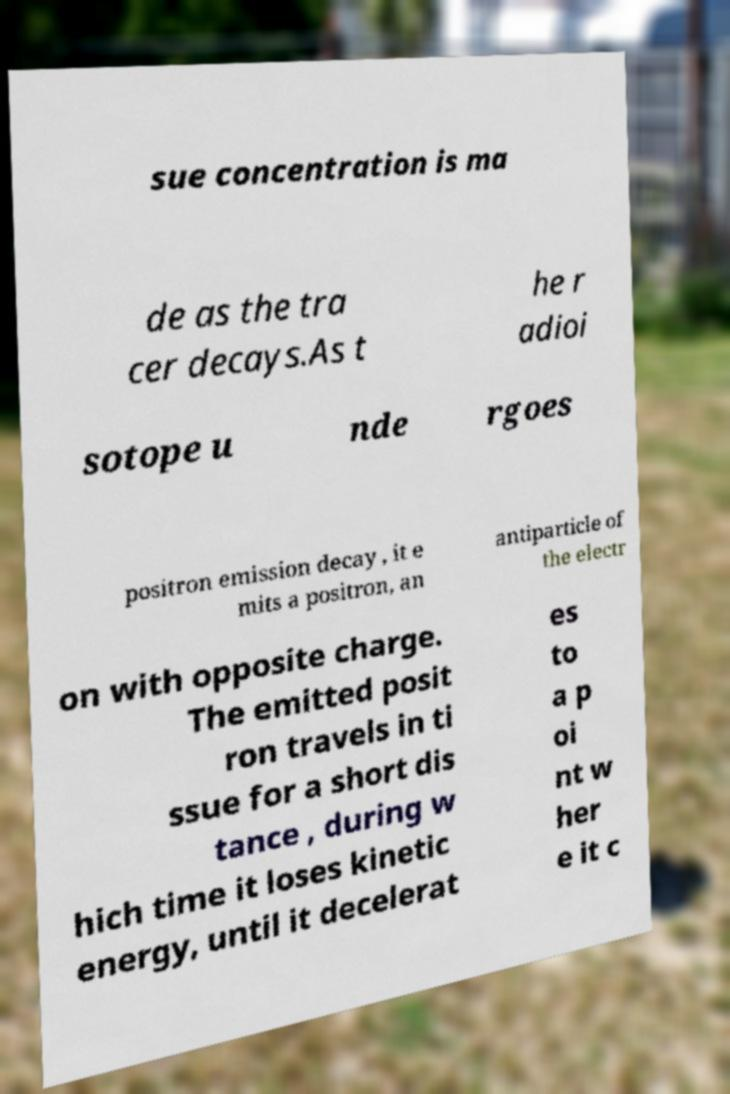Could you extract and type out the text from this image? sue concentration is ma de as the tra cer decays.As t he r adioi sotope u nde rgoes positron emission decay , it e mits a positron, an antiparticle of the electr on with opposite charge. The emitted posit ron travels in ti ssue for a short dis tance , during w hich time it loses kinetic energy, until it decelerat es to a p oi nt w her e it c 